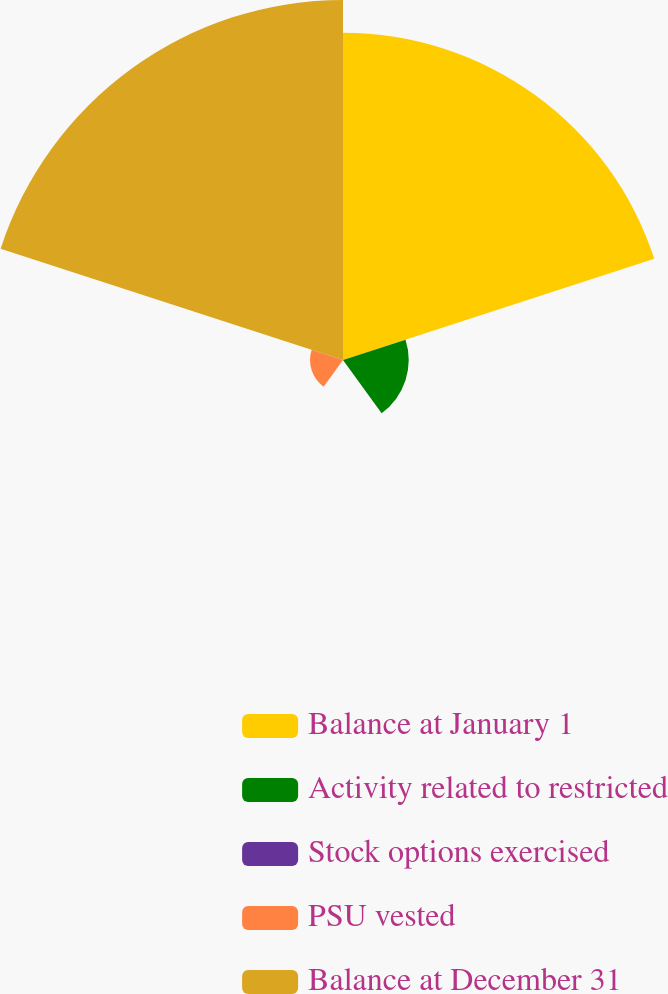Convert chart to OTSL. <chart><loc_0><loc_0><loc_500><loc_500><pie_chart><fcel>Balance at January 1<fcel>Activity related to restricted<fcel>Stock options exercised<fcel>PSU vested<fcel>Balance at December 31<nl><fcel>41.63%<fcel>8.36%<fcel>0.03%<fcel>4.19%<fcel>45.79%<nl></chart> 